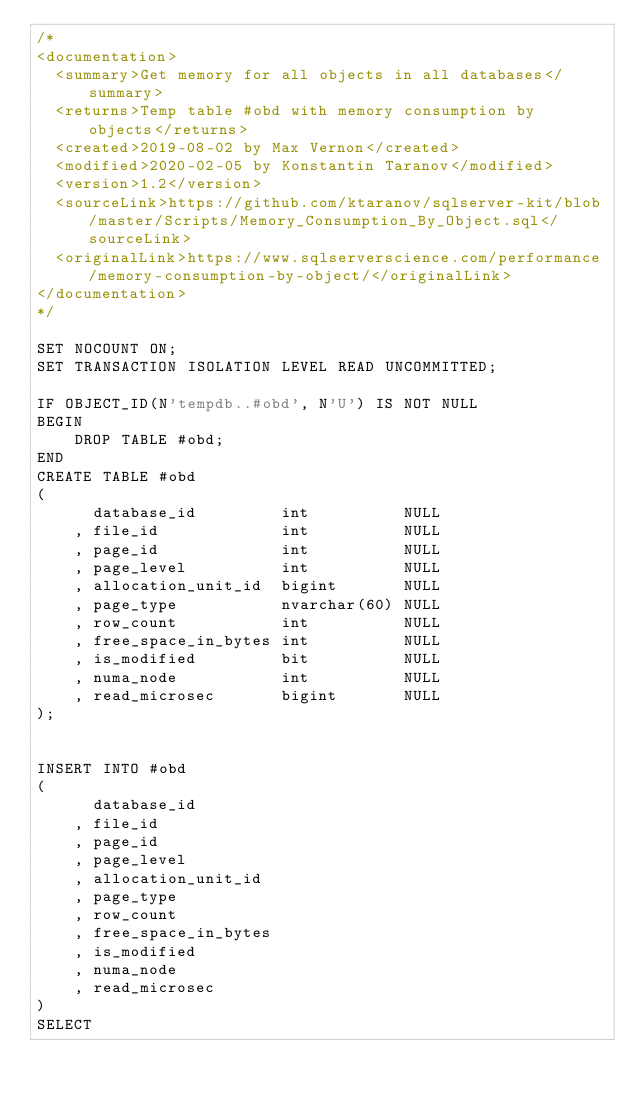<code> <loc_0><loc_0><loc_500><loc_500><_SQL_>/*
<documentation>
  <summary>Get memory for all objects in all databases</summary>
  <returns>Temp table #obd with memory consumption by objects</returns>
  <created>2019-08-02 by Max Vernon</created>
  <modified>2020-02-05 by Konstantin Taranov</modified>
  <version>1.2</version>
  <sourceLink>https://github.com/ktaranov/sqlserver-kit/blob/master/Scripts/Memory_Consumption_By_Object.sql</sourceLink>
  <originalLink>https://www.sqlserverscience.com/performance/memory-consumption-by-object/</originalLink>
</documentation>
*/

SET NOCOUNT ON;
SET TRANSACTION ISOLATION LEVEL READ UNCOMMITTED;

IF OBJECT_ID(N'tempdb..#obd', N'U') IS NOT NULL
BEGIN
    DROP TABLE #obd;
END
CREATE TABLE #obd
(
      database_id         int          NULL
    , file_id             int          NULL
    , page_id             int          NULL
    , page_level          int          NULL
    , allocation_unit_id  bigint       NULL
    , page_type           nvarchar(60) NULL
    , row_count           int          NULL
    , free_space_in_bytes int          NULL
    , is_modified         bit          NULL
    , numa_node           int          NULL
    , read_microsec       bigint       NULL
);


INSERT INTO #obd
(
      database_id
    , file_id
    , page_id
    , page_level
    , allocation_unit_id
    , page_type
    , row_count
    , free_space_in_bytes
    , is_modified
    , numa_node
    , read_microsec
)
SELECT</code> 